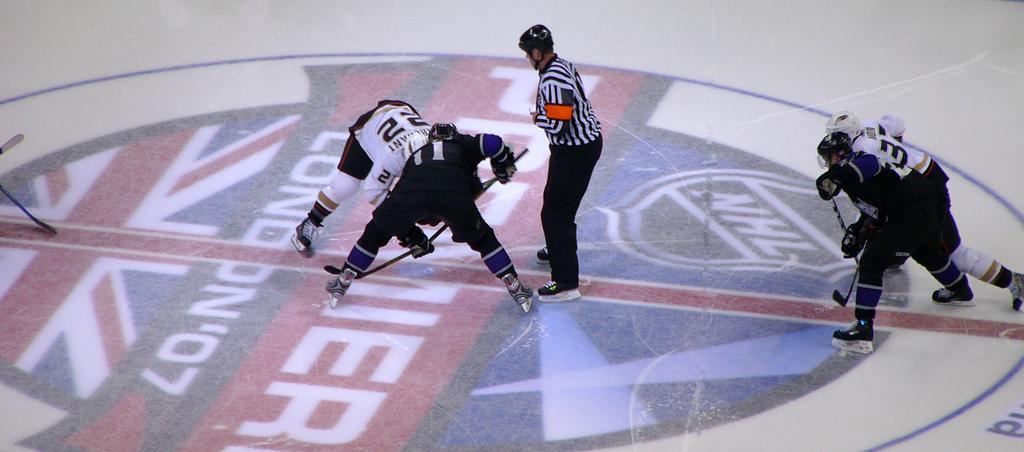Describe this image in one or two sentences. In this picture we can see a few people holding sticks in their hands and wore skating shoes. We can see a person standing on the path. There is a painting on the floor. 